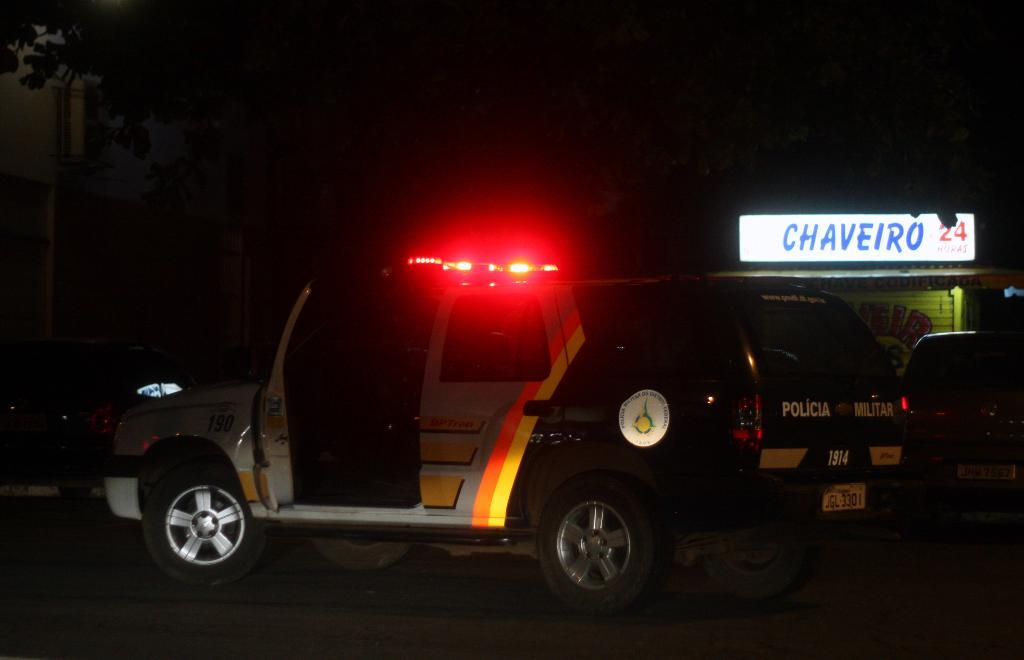What is the main subject of the image? The main subject of the image is a car. Are there any additional features on the car? There are lights visible on the car. What can be seen in the background of the image? There is a hoarding in the background of the image. How would you describe the lighting conditions in the image? The background of the image is dark. What type of plants can be seen growing on the car in the image? There are no plants growing on the car in the image. Can you tell me how many steps it takes to reach the car from the hoarding in the image? The image does not provide enough information to determine the number of steps or the distance between the car and the hoarding. 